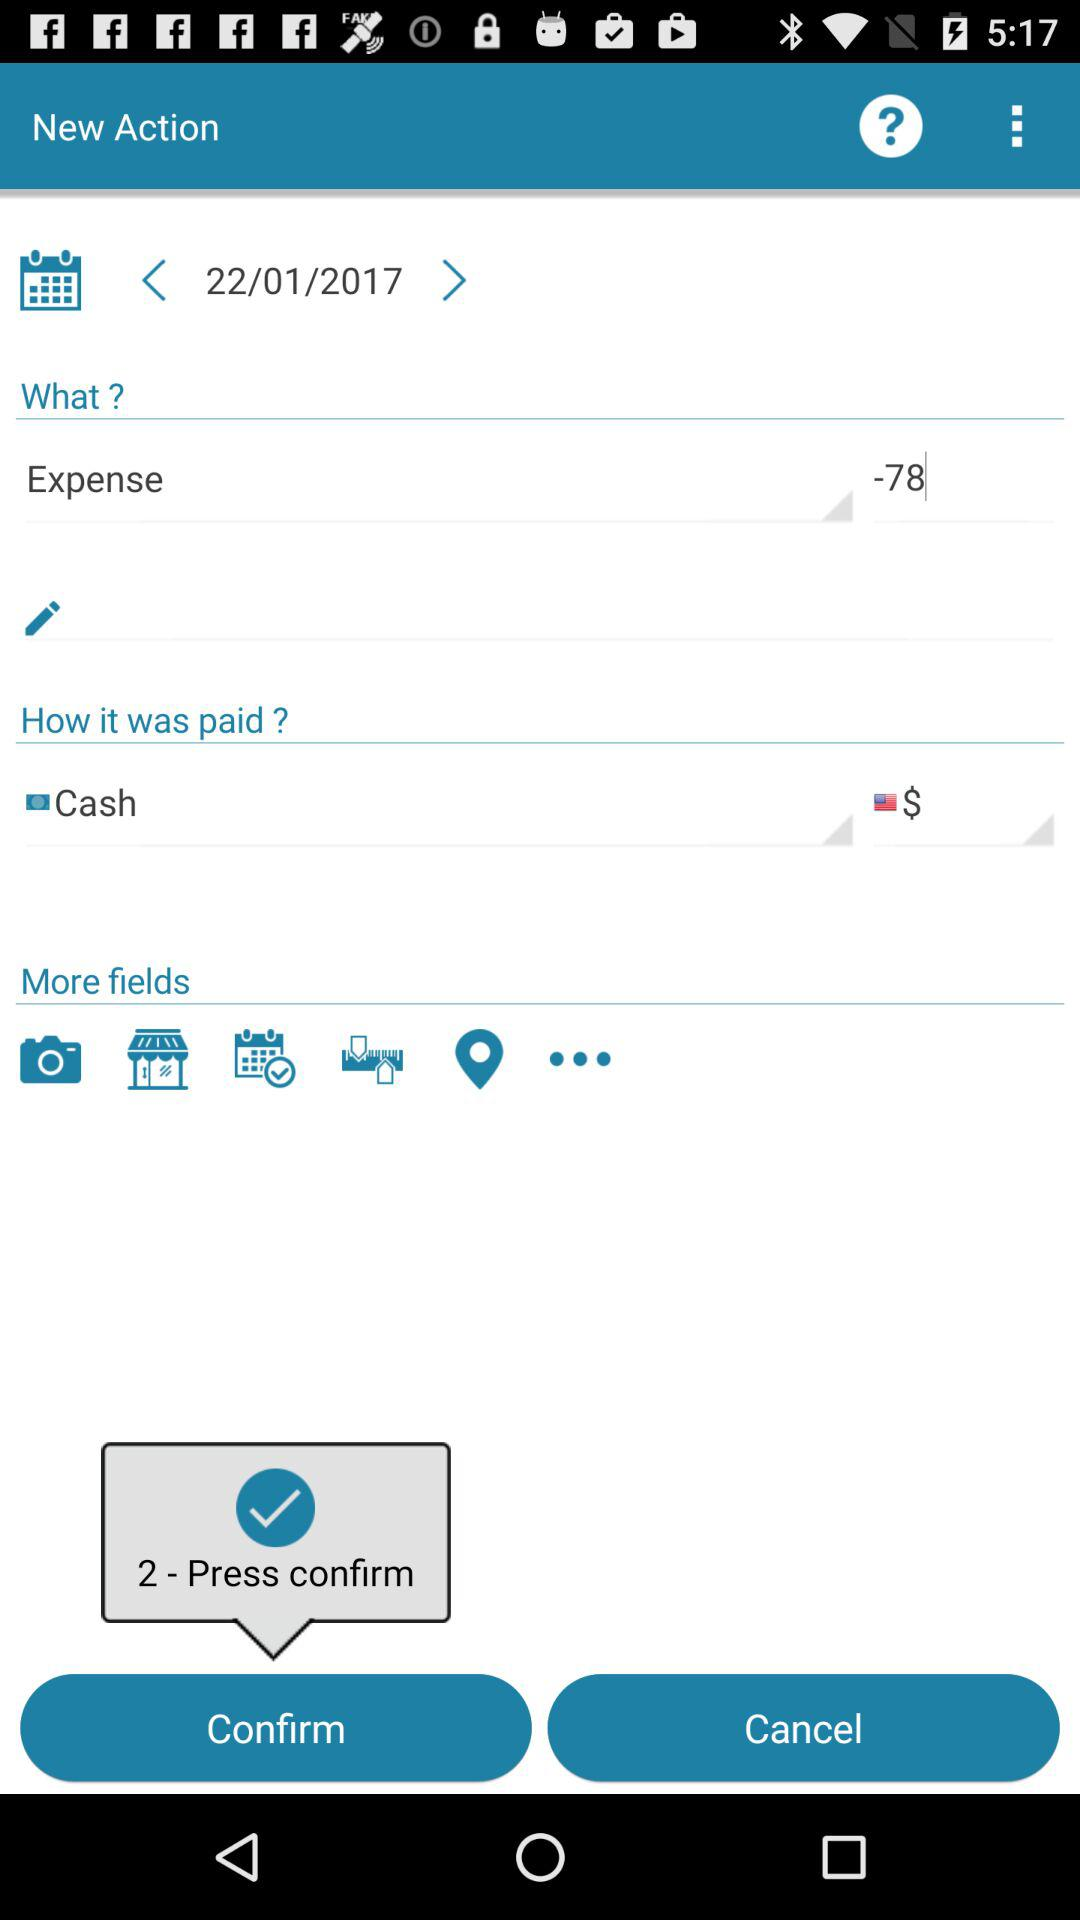What is the shown date? The shown date is January 22, 2017. 